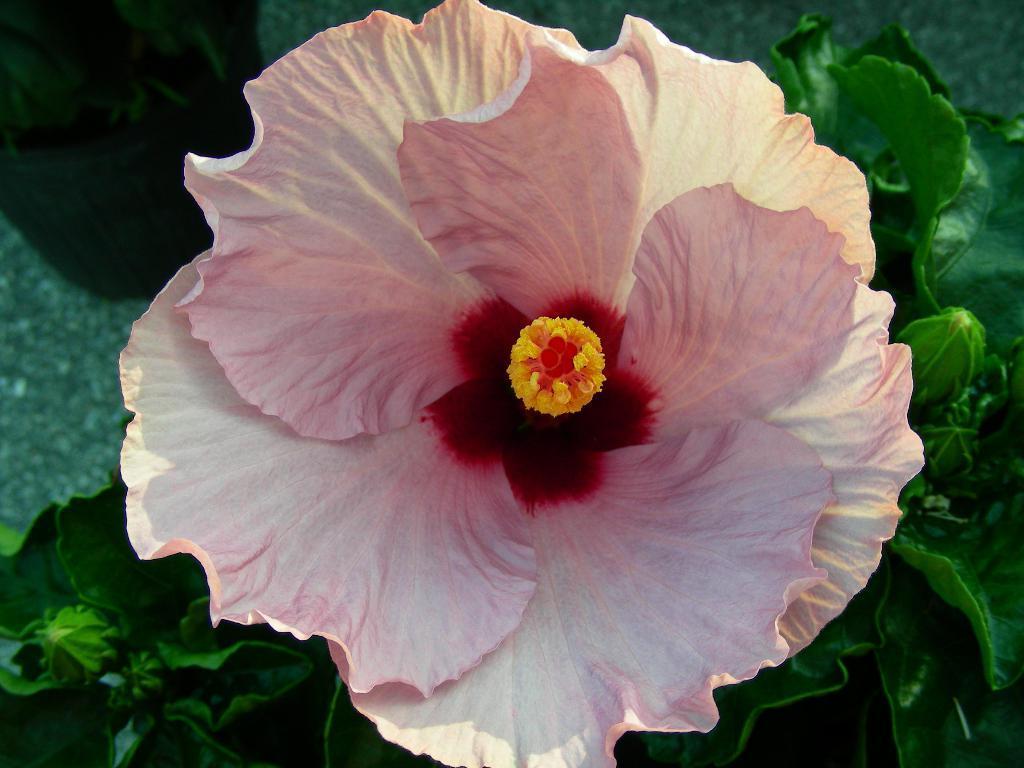How would you summarize this image in a sentence or two? In this image I can see the pink color flower to the green color plant. 